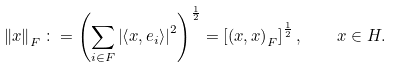<formula> <loc_0><loc_0><loc_500><loc_500>\left \| x \right \| _ { F } \colon = \left ( \sum _ { i \in F } \left | \left \langle x , e _ { i } \right \rangle \right | ^ { 2 } \right ) ^ { \frac { 1 } { 2 } } = \left [ \left ( x , x \right ) _ { F } \right ] ^ { \frac { 1 } { 2 } } , \quad x \in H .</formula> 